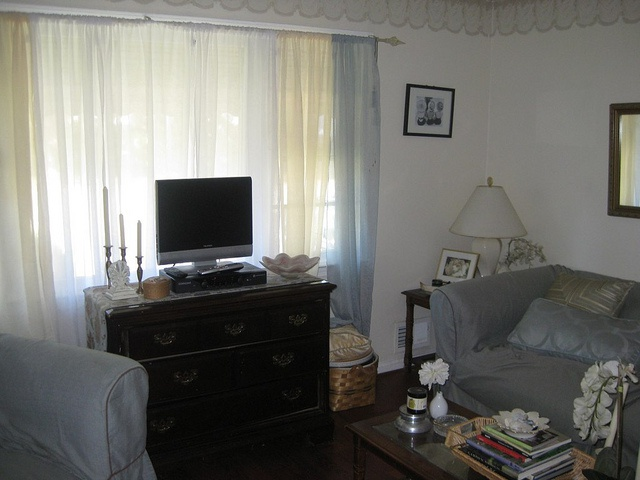Describe the objects in this image and their specific colors. I can see couch in gray, black, and purple tones, chair in gray, black, and purple tones, tv in gray, black, and lightgray tones, book in gray, black, darkgreen, and olive tones, and book in gray, black, and darkgreen tones in this image. 